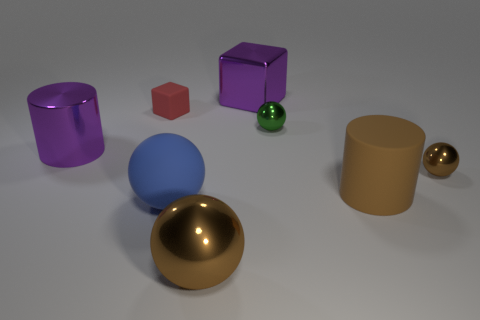Subtract 1 spheres. How many spheres are left? 3 Subtract all blue blocks. Subtract all red balls. How many blocks are left? 2 Add 2 big metal spheres. How many objects exist? 10 Subtract all cubes. How many objects are left? 6 Add 5 tiny blue matte cylinders. How many tiny blue matte cylinders exist? 5 Subtract 0 cyan blocks. How many objects are left? 8 Subtract all tiny cyan shiny cubes. Subtract all green things. How many objects are left? 7 Add 4 large spheres. How many large spheres are left? 6 